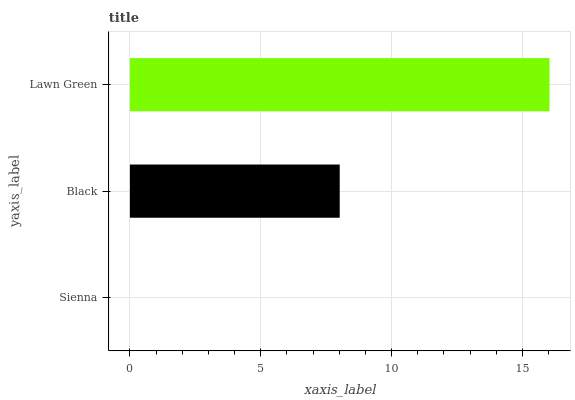Is Sienna the minimum?
Answer yes or no. Yes. Is Lawn Green the maximum?
Answer yes or no. Yes. Is Black the minimum?
Answer yes or no. No. Is Black the maximum?
Answer yes or no. No. Is Black greater than Sienna?
Answer yes or no. Yes. Is Sienna less than Black?
Answer yes or no. Yes. Is Sienna greater than Black?
Answer yes or no. No. Is Black less than Sienna?
Answer yes or no. No. Is Black the high median?
Answer yes or no. Yes. Is Black the low median?
Answer yes or no. Yes. Is Lawn Green the high median?
Answer yes or no. No. Is Lawn Green the low median?
Answer yes or no. No. 